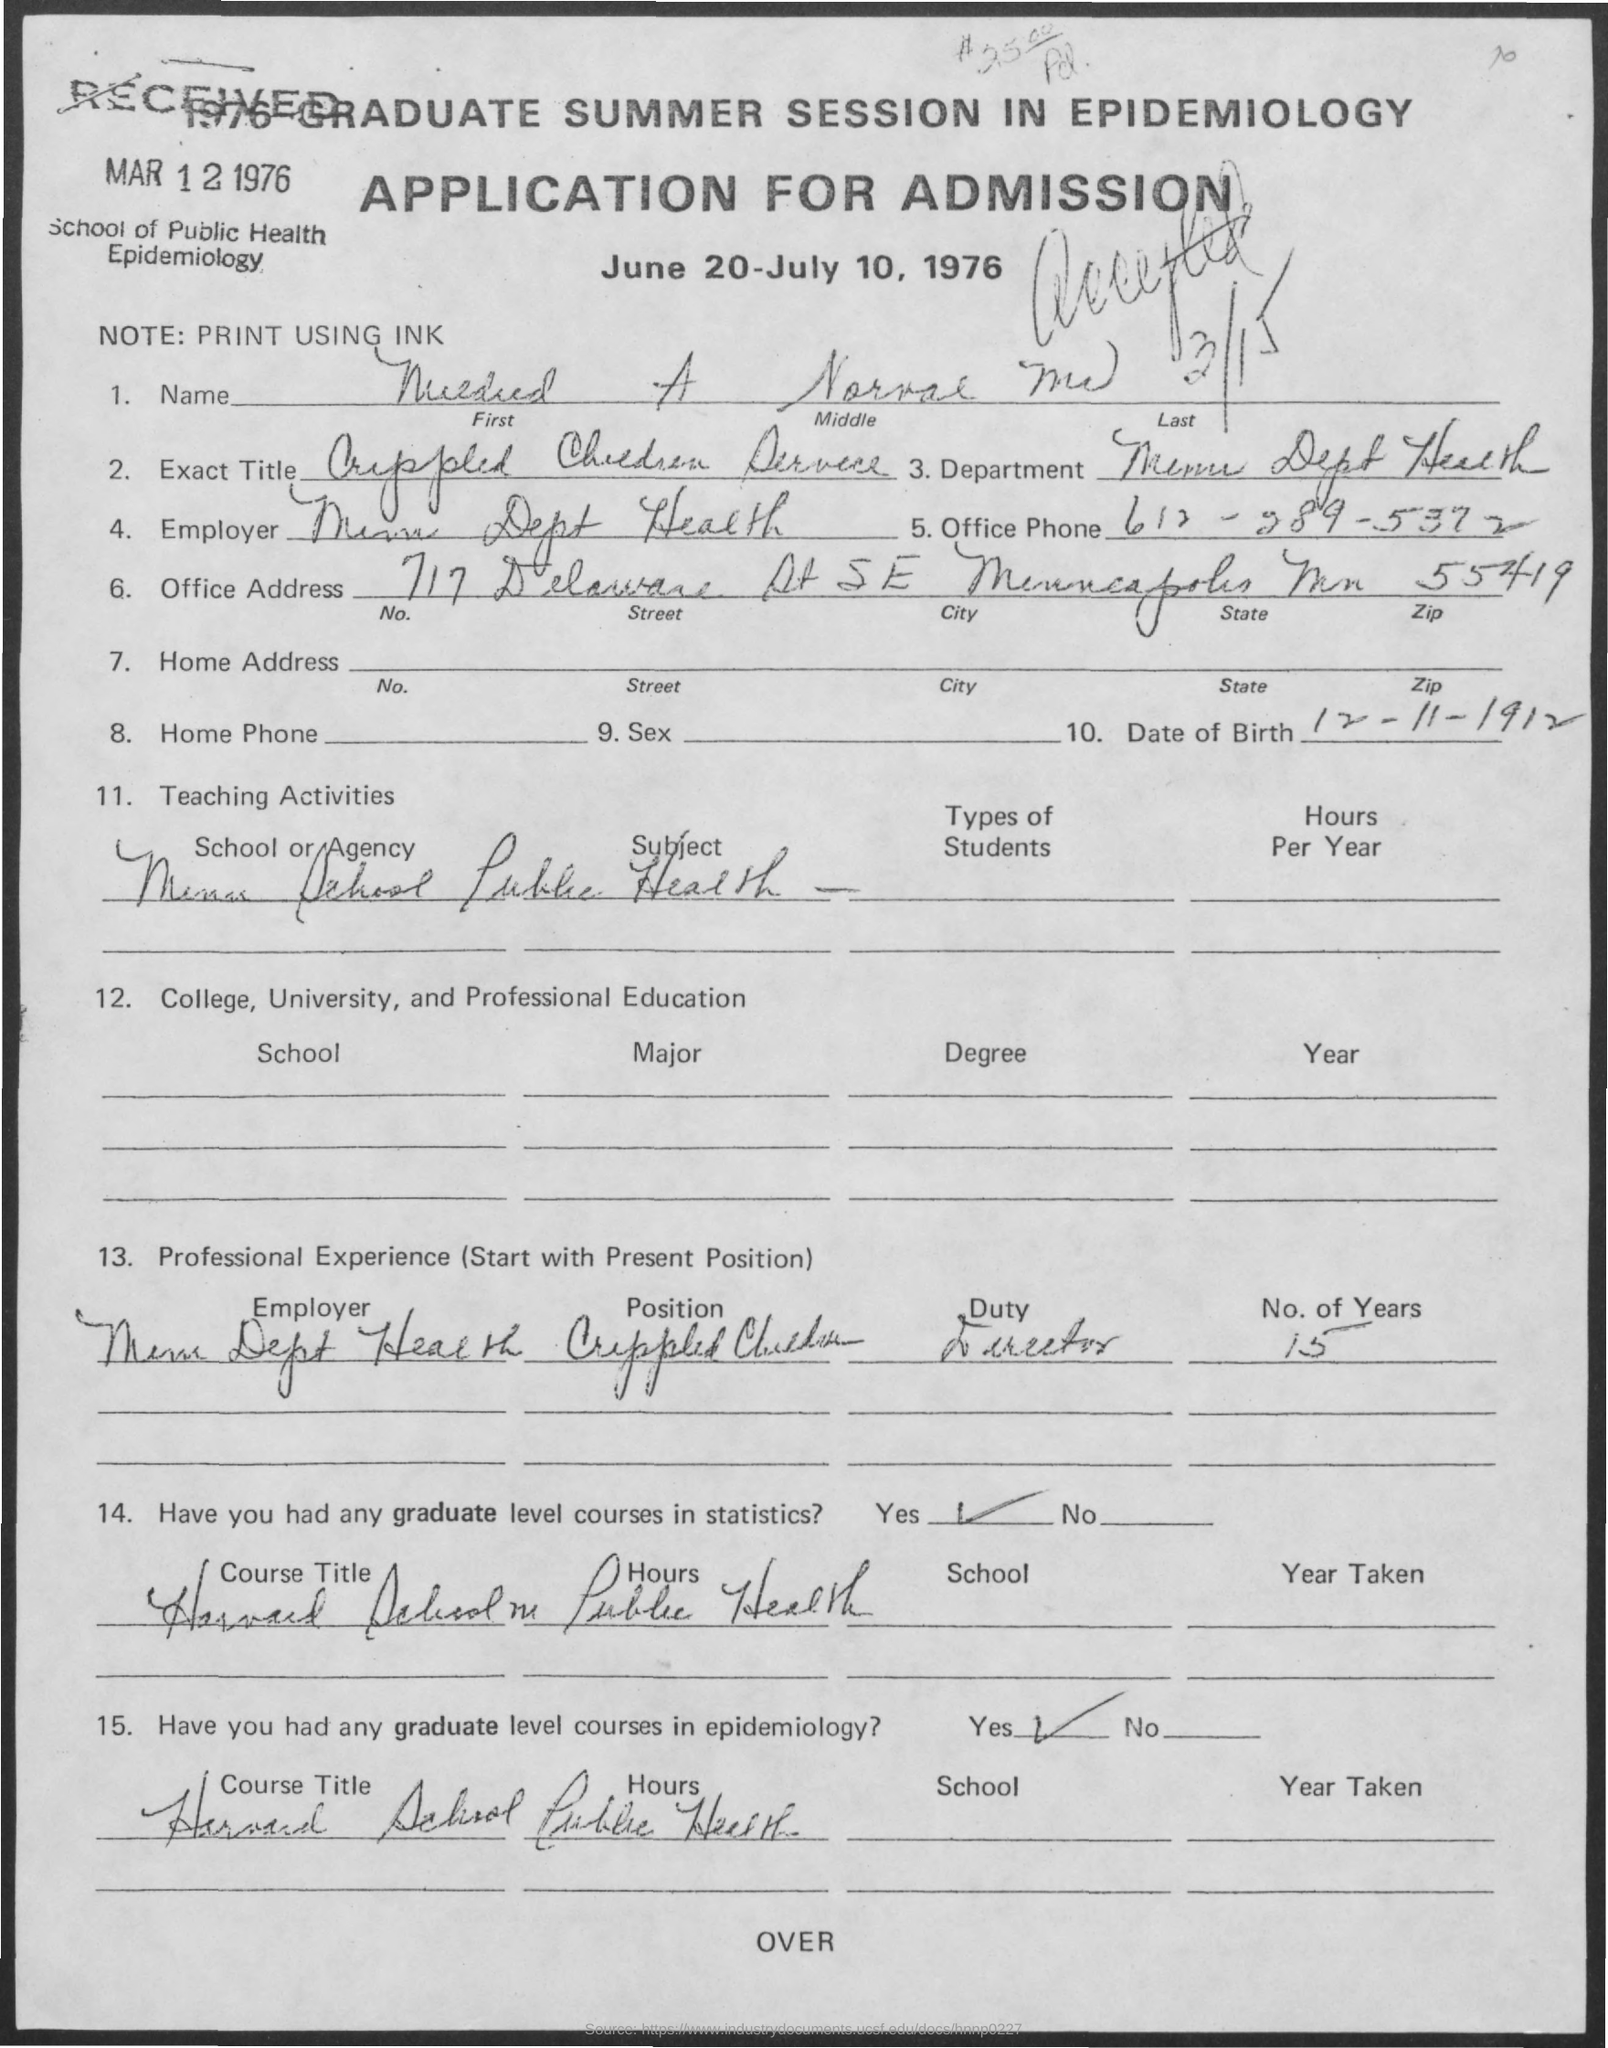Highlight a few significant elements in this photo. The note mentioned in the given application is 'PRINT USING INK.' The given application states the name of the school as the School of Public Health Epidemiology. The date of birth mentioned in the given application is November 12, 1912. Yes, he does have graduate level courses in statistics. Yes, he has graduate-level courses in epidemiology. 